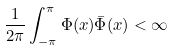<formula> <loc_0><loc_0><loc_500><loc_500>\frac { 1 } { 2 \pi } \int _ { - \pi } ^ { \pi } \Phi ( x ) \bar { \Phi } ( x ) < \infty</formula> 